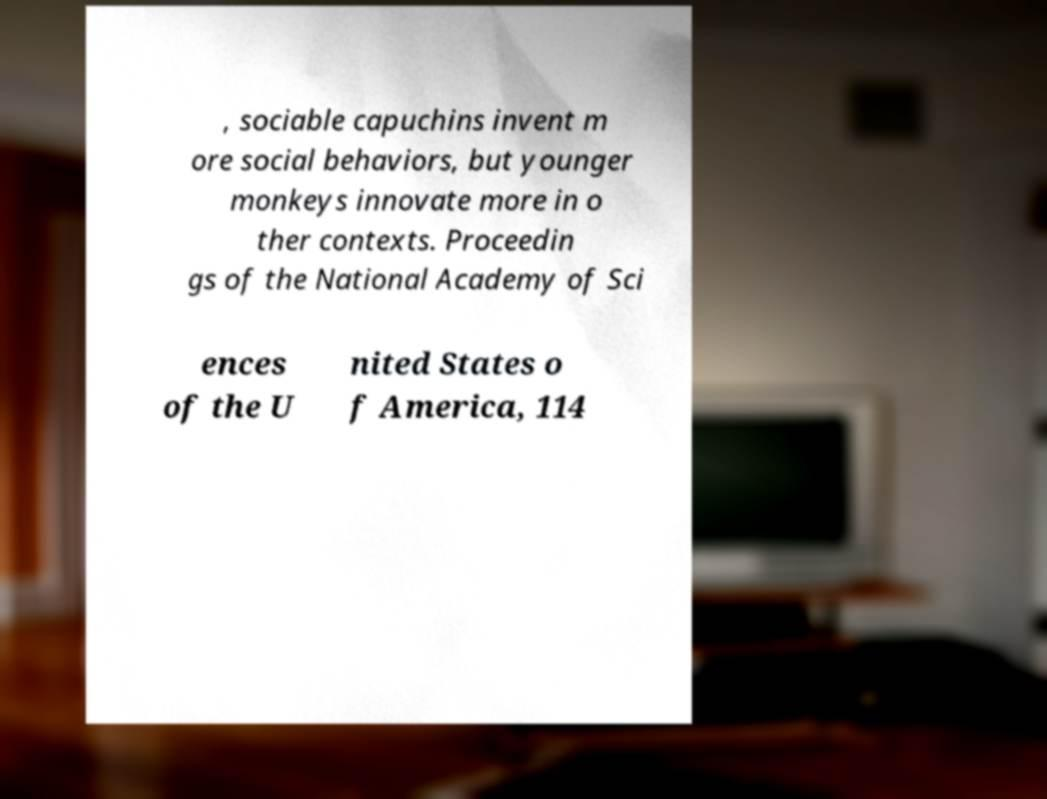There's text embedded in this image that I need extracted. Can you transcribe it verbatim? , sociable capuchins invent m ore social behaviors, but younger monkeys innovate more in o ther contexts. Proceedin gs of the National Academy of Sci ences of the U nited States o f America, 114 